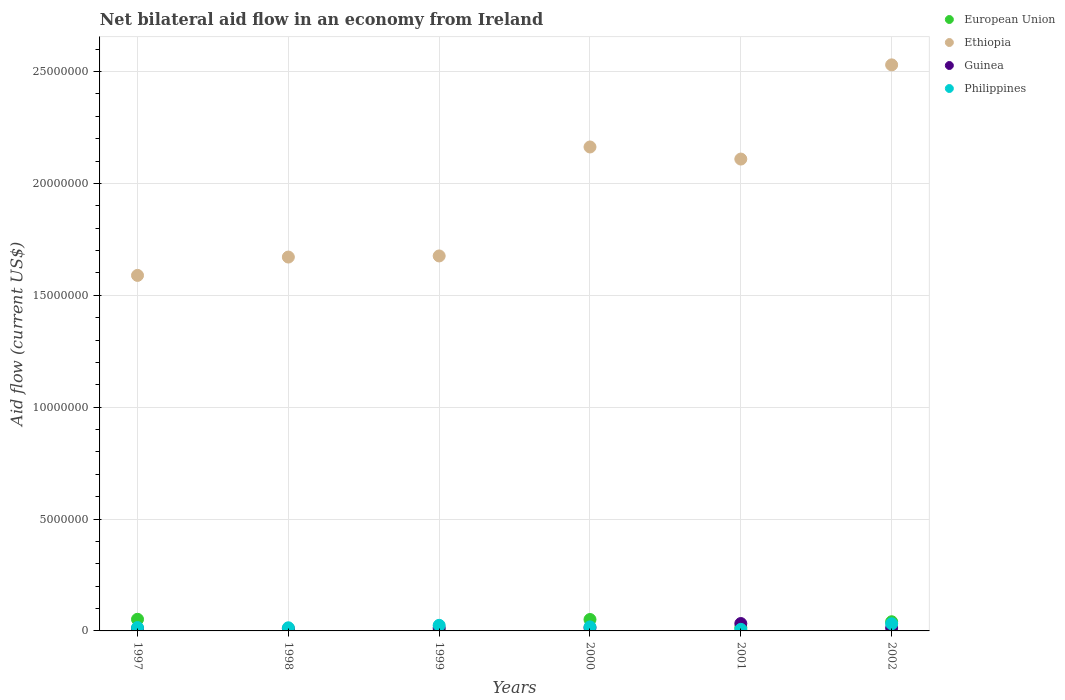Is the number of dotlines equal to the number of legend labels?
Offer a very short reply. Yes. Across all years, what is the maximum net bilateral aid flow in European Union?
Your answer should be compact. 5.20e+05. Across all years, what is the minimum net bilateral aid flow in Guinea?
Your answer should be compact. 1.00e+05. In which year was the net bilateral aid flow in Guinea minimum?
Your answer should be compact. 1998. What is the total net bilateral aid flow in Ethiopia in the graph?
Provide a succinct answer. 1.17e+08. What is the difference between the net bilateral aid flow in Ethiopia in 1997 and that in 2000?
Provide a succinct answer. -5.74e+06. What is the difference between the net bilateral aid flow in Philippines in 2001 and the net bilateral aid flow in Ethiopia in 2000?
Your answer should be compact. -2.16e+07. What is the average net bilateral aid flow in Guinea per year?
Your answer should be compact. 1.57e+05. In the year 2001, what is the difference between the net bilateral aid flow in Guinea and net bilateral aid flow in Ethiopia?
Provide a short and direct response. -2.08e+07. In how many years, is the net bilateral aid flow in Guinea greater than 13000000 US$?
Your answer should be very brief. 0. What is the ratio of the net bilateral aid flow in Philippines in 1997 to that in 2001?
Your answer should be very brief. 2.14. What is the difference between the highest and the lowest net bilateral aid flow in European Union?
Provide a succinct answer. 5.10e+05. In how many years, is the net bilateral aid flow in European Union greater than the average net bilateral aid flow in European Union taken over all years?
Give a very brief answer. 3. Is it the case that in every year, the sum of the net bilateral aid flow in European Union and net bilateral aid flow in Ethiopia  is greater than the sum of net bilateral aid flow in Guinea and net bilateral aid flow in Philippines?
Your answer should be very brief. No. Does the net bilateral aid flow in Guinea monotonically increase over the years?
Make the answer very short. No. Is the net bilateral aid flow in Ethiopia strictly greater than the net bilateral aid flow in European Union over the years?
Keep it short and to the point. Yes. How many years are there in the graph?
Your answer should be very brief. 6. What is the difference between two consecutive major ticks on the Y-axis?
Make the answer very short. 5.00e+06. Does the graph contain any zero values?
Provide a short and direct response. No. How many legend labels are there?
Your response must be concise. 4. What is the title of the graph?
Your answer should be very brief. Net bilateral aid flow in an economy from Ireland. Does "Maldives" appear as one of the legend labels in the graph?
Provide a short and direct response. No. What is the label or title of the X-axis?
Your answer should be very brief. Years. What is the Aid flow (current US$) in European Union in 1997?
Provide a short and direct response. 5.20e+05. What is the Aid flow (current US$) in Ethiopia in 1997?
Keep it short and to the point. 1.59e+07. What is the Aid flow (current US$) of Guinea in 1997?
Your answer should be very brief. 1.10e+05. What is the Aid flow (current US$) of Philippines in 1997?
Give a very brief answer. 1.50e+05. What is the Aid flow (current US$) in European Union in 1998?
Your answer should be very brief. 10000. What is the Aid flow (current US$) in Ethiopia in 1998?
Provide a succinct answer. 1.67e+07. What is the Aid flow (current US$) in Ethiopia in 1999?
Keep it short and to the point. 1.68e+07. What is the Aid flow (current US$) in European Union in 2000?
Offer a very short reply. 5.10e+05. What is the Aid flow (current US$) of Ethiopia in 2000?
Ensure brevity in your answer.  2.16e+07. What is the Aid flow (current US$) in European Union in 2001?
Keep it short and to the point. 1.50e+05. What is the Aid flow (current US$) of Ethiopia in 2001?
Your answer should be very brief. 2.11e+07. What is the Aid flow (current US$) of Guinea in 2001?
Offer a terse response. 3.30e+05. What is the Aid flow (current US$) in Ethiopia in 2002?
Your answer should be very brief. 2.53e+07. Across all years, what is the maximum Aid flow (current US$) of European Union?
Offer a terse response. 5.20e+05. Across all years, what is the maximum Aid flow (current US$) of Ethiopia?
Make the answer very short. 2.53e+07. Across all years, what is the maximum Aid flow (current US$) in Guinea?
Give a very brief answer. 3.30e+05. Across all years, what is the minimum Aid flow (current US$) in Ethiopia?
Provide a short and direct response. 1.59e+07. What is the total Aid flow (current US$) in European Union in the graph?
Offer a very short reply. 1.63e+06. What is the total Aid flow (current US$) of Ethiopia in the graph?
Your answer should be compact. 1.17e+08. What is the total Aid flow (current US$) of Guinea in the graph?
Your answer should be compact. 9.40e+05. What is the total Aid flow (current US$) of Philippines in the graph?
Your answer should be compact. 1.11e+06. What is the difference between the Aid flow (current US$) in European Union in 1997 and that in 1998?
Provide a succinct answer. 5.10e+05. What is the difference between the Aid flow (current US$) of Ethiopia in 1997 and that in 1998?
Make the answer very short. -8.20e+05. What is the difference between the Aid flow (current US$) of Guinea in 1997 and that in 1998?
Provide a short and direct response. 10000. What is the difference between the Aid flow (current US$) of Philippines in 1997 and that in 1998?
Offer a very short reply. 10000. What is the difference between the Aid flow (current US$) of European Union in 1997 and that in 1999?
Make the answer very short. 4.90e+05. What is the difference between the Aid flow (current US$) in Ethiopia in 1997 and that in 1999?
Your answer should be very brief. -8.70e+05. What is the difference between the Aid flow (current US$) of Guinea in 1997 and that in 1999?
Give a very brief answer. -2.00e+04. What is the difference between the Aid flow (current US$) in Philippines in 1997 and that in 1999?
Keep it short and to the point. -1.00e+05. What is the difference between the Aid flow (current US$) in European Union in 1997 and that in 2000?
Offer a very short reply. 10000. What is the difference between the Aid flow (current US$) in Ethiopia in 1997 and that in 2000?
Provide a short and direct response. -5.74e+06. What is the difference between the Aid flow (current US$) of Guinea in 1997 and that in 2000?
Your answer should be compact. -3.00e+04. What is the difference between the Aid flow (current US$) of European Union in 1997 and that in 2001?
Your answer should be very brief. 3.70e+05. What is the difference between the Aid flow (current US$) of Ethiopia in 1997 and that in 2001?
Keep it short and to the point. -5.20e+06. What is the difference between the Aid flow (current US$) of Guinea in 1997 and that in 2001?
Offer a terse response. -2.20e+05. What is the difference between the Aid flow (current US$) in Philippines in 1997 and that in 2001?
Give a very brief answer. 8.00e+04. What is the difference between the Aid flow (current US$) of European Union in 1997 and that in 2002?
Your answer should be compact. 1.10e+05. What is the difference between the Aid flow (current US$) in Ethiopia in 1997 and that in 2002?
Provide a short and direct response. -9.41e+06. What is the difference between the Aid flow (current US$) in Guinea in 1997 and that in 2002?
Provide a short and direct response. -2.00e+04. What is the difference between the Aid flow (current US$) of Philippines in 1997 and that in 2002?
Your response must be concise. -1.70e+05. What is the difference between the Aid flow (current US$) in European Union in 1998 and that in 1999?
Give a very brief answer. -2.00e+04. What is the difference between the Aid flow (current US$) of Ethiopia in 1998 and that in 1999?
Ensure brevity in your answer.  -5.00e+04. What is the difference between the Aid flow (current US$) in Guinea in 1998 and that in 1999?
Ensure brevity in your answer.  -3.00e+04. What is the difference between the Aid flow (current US$) of Philippines in 1998 and that in 1999?
Your answer should be compact. -1.10e+05. What is the difference between the Aid flow (current US$) of European Union in 1998 and that in 2000?
Your response must be concise. -5.00e+05. What is the difference between the Aid flow (current US$) of Ethiopia in 1998 and that in 2000?
Provide a short and direct response. -4.92e+06. What is the difference between the Aid flow (current US$) in Philippines in 1998 and that in 2000?
Give a very brief answer. -4.00e+04. What is the difference between the Aid flow (current US$) of European Union in 1998 and that in 2001?
Provide a short and direct response. -1.40e+05. What is the difference between the Aid flow (current US$) of Ethiopia in 1998 and that in 2001?
Your answer should be very brief. -4.38e+06. What is the difference between the Aid flow (current US$) of Philippines in 1998 and that in 2001?
Ensure brevity in your answer.  7.00e+04. What is the difference between the Aid flow (current US$) in European Union in 1998 and that in 2002?
Keep it short and to the point. -4.00e+05. What is the difference between the Aid flow (current US$) of Ethiopia in 1998 and that in 2002?
Make the answer very short. -8.59e+06. What is the difference between the Aid flow (current US$) of Guinea in 1998 and that in 2002?
Provide a short and direct response. -3.00e+04. What is the difference between the Aid flow (current US$) in European Union in 1999 and that in 2000?
Provide a short and direct response. -4.80e+05. What is the difference between the Aid flow (current US$) of Ethiopia in 1999 and that in 2000?
Offer a very short reply. -4.87e+06. What is the difference between the Aid flow (current US$) of Guinea in 1999 and that in 2000?
Keep it short and to the point. -10000. What is the difference between the Aid flow (current US$) in Ethiopia in 1999 and that in 2001?
Your response must be concise. -4.33e+06. What is the difference between the Aid flow (current US$) in Philippines in 1999 and that in 2001?
Ensure brevity in your answer.  1.80e+05. What is the difference between the Aid flow (current US$) of European Union in 1999 and that in 2002?
Your answer should be compact. -3.80e+05. What is the difference between the Aid flow (current US$) of Ethiopia in 1999 and that in 2002?
Your answer should be compact. -8.54e+06. What is the difference between the Aid flow (current US$) of Ethiopia in 2000 and that in 2001?
Provide a short and direct response. 5.40e+05. What is the difference between the Aid flow (current US$) in Guinea in 2000 and that in 2001?
Offer a terse response. -1.90e+05. What is the difference between the Aid flow (current US$) in Ethiopia in 2000 and that in 2002?
Offer a terse response. -3.67e+06. What is the difference between the Aid flow (current US$) in Guinea in 2000 and that in 2002?
Give a very brief answer. 10000. What is the difference between the Aid flow (current US$) of Philippines in 2000 and that in 2002?
Your answer should be compact. -1.40e+05. What is the difference between the Aid flow (current US$) in European Union in 2001 and that in 2002?
Your answer should be compact. -2.60e+05. What is the difference between the Aid flow (current US$) in Ethiopia in 2001 and that in 2002?
Offer a terse response. -4.21e+06. What is the difference between the Aid flow (current US$) in Philippines in 2001 and that in 2002?
Your response must be concise. -2.50e+05. What is the difference between the Aid flow (current US$) in European Union in 1997 and the Aid flow (current US$) in Ethiopia in 1998?
Provide a short and direct response. -1.62e+07. What is the difference between the Aid flow (current US$) in European Union in 1997 and the Aid flow (current US$) in Guinea in 1998?
Your response must be concise. 4.20e+05. What is the difference between the Aid flow (current US$) of European Union in 1997 and the Aid flow (current US$) of Philippines in 1998?
Keep it short and to the point. 3.80e+05. What is the difference between the Aid flow (current US$) in Ethiopia in 1997 and the Aid flow (current US$) in Guinea in 1998?
Offer a terse response. 1.58e+07. What is the difference between the Aid flow (current US$) of Ethiopia in 1997 and the Aid flow (current US$) of Philippines in 1998?
Make the answer very short. 1.58e+07. What is the difference between the Aid flow (current US$) of European Union in 1997 and the Aid flow (current US$) of Ethiopia in 1999?
Provide a succinct answer. -1.62e+07. What is the difference between the Aid flow (current US$) of European Union in 1997 and the Aid flow (current US$) of Guinea in 1999?
Give a very brief answer. 3.90e+05. What is the difference between the Aid flow (current US$) in Ethiopia in 1997 and the Aid flow (current US$) in Guinea in 1999?
Your response must be concise. 1.58e+07. What is the difference between the Aid flow (current US$) of Ethiopia in 1997 and the Aid flow (current US$) of Philippines in 1999?
Give a very brief answer. 1.56e+07. What is the difference between the Aid flow (current US$) of European Union in 1997 and the Aid flow (current US$) of Ethiopia in 2000?
Keep it short and to the point. -2.11e+07. What is the difference between the Aid flow (current US$) in Ethiopia in 1997 and the Aid flow (current US$) in Guinea in 2000?
Your answer should be very brief. 1.58e+07. What is the difference between the Aid flow (current US$) of Ethiopia in 1997 and the Aid flow (current US$) of Philippines in 2000?
Offer a terse response. 1.57e+07. What is the difference between the Aid flow (current US$) in European Union in 1997 and the Aid flow (current US$) in Ethiopia in 2001?
Your response must be concise. -2.06e+07. What is the difference between the Aid flow (current US$) in European Union in 1997 and the Aid flow (current US$) in Guinea in 2001?
Ensure brevity in your answer.  1.90e+05. What is the difference between the Aid flow (current US$) of European Union in 1997 and the Aid flow (current US$) of Philippines in 2001?
Your answer should be very brief. 4.50e+05. What is the difference between the Aid flow (current US$) in Ethiopia in 1997 and the Aid flow (current US$) in Guinea in 2001?
Your response must be concise. 1.56e+07. What is the difference between the Aid flow (current US$) in Ethiopia in 1997 and the Aid flow (current US$) in Philippines in 2001?
Offer a very short reply. 1.58e+07. What is the difference between the Aid flow (current US$) of Guinea in 1997 and the Aid flow (current US$) of Philippines in 2001?
Offer a terse response. 4.00e+04. What is the difference between the Aid flow (current US$) of European Union in 1997 and the Aid flow (current US$) of Ethiopia in 2002?
Ensure brevity in your answer.  -2.48e+07. What is the difference between the Aid flow (current US$) of European Union in 1997 and the Aid flow (current US$) of Guinea in 2002?
Your response must be concise. 3.90e+05. What is the difference between the Aid flow (current US$) in Ethiopia in 1997 and the Aid flow (current US$) in Guinea in 2002?
Offer a terse response. 1.58e+07. What is the difference between the Aid flow (current US$) in Ethiopia in 1997 and the Aid flow (current US$) in Philippines in 2002?
Provide a short and direct response. 1.56e+07. What is the difference between the Aid flow (current US$) of European Union in 1998 and the Aid flow (current US$) of Ethiopia in 1999?
Provide a short and direct response. -1.68e+07. What is the difference between the Aid flow (current US$) in Ethiopia in 1998 and the Aid flow (current US$) in Guinea in 1999?
Your answer should be compact. 1.66e+07. What is the difference between the Aid flow (current US$) of Ethiopia in 1998 and the Aid flow (current US$) of Philippines in 1999?
Your response must be concise. 1.65e+07. What is the difference between the Aid flow (current US$) in Guinea in 1998 and the Aid flow (current US$) in Philippines in 1999?
Ensure brevity in your answer.  -1.50e+05. What is the difference between the Aid flow (current US$) of European Union in 1998 and the Aid flow (current US$) of Ethiopia in 2000?
Provide a short and direct response. -2.16e+07. What is the difference between the Aid flow (current US$) of European Union in 1998 and the Aid flow (current US$) of Guinea in 2000?
Ensure brevity in your answer.  -1.30e+05. What is the difference between the Aid flow (current US$) of European Union in 1998 and the Aid flow (current US$) of Philippines in 2000?
Offer a very short reply. -1.70e+05. What is the difference between the Aid flow (current US$) of Ethiopia in 1998 and the Aid flow (current US$) of Guinea in 2000?
Provide a succinct answer. 1.66e+07. What is the difference between the Aid flow (current US$) in Ethiopia in 1998 and the Aid flow (current US$) in Philippines in 2000?
Your response must be concise. 1.65e+07. What is the difference between the Aid flow (current US$) of Guinea in 1998 and the Aid flow (current US$) of Philippines in 2000?
Provide a succinct answer. -8.00e+04. What is the difference between the Aid flow (current US$) of European Union in 1998 and the Aid flow (current US$) of Ethiopia in 2001?
Keep it short and to the point. -2.11e+07. What is the difference between the Aid flow (current US$) of European Union in 1998 and the Aid flow (current US$) of Guinea in 2001?
Your answer should be very brief. -3.20e+05. What is the difference between the Aid flow (current US$) of European Union in 1998 and the Aid flow (current US$) of Philippines in 2001?
Give a very brief answer. -6.00e+04. What is the difference between the Aid flow (current US$) in Ethiopia in 1998 and the Aid flow (current US$) in Guinea in 2001?
Offer a terse response. 1.64e+07. What is the difference between the Aid flow (current US$) of Ethiopia in 1998 and the Aid flow (current US$) of Philippines in 2001?
Provide a short and direct response. 1.66e+07. What is the difference between the Aid flow (current US$) of European Union in 1998 and the Aid flow (current US$) of Ethiopia in 2002?
Give a very brief answer. -2.53e+07. What is the difference between the Aid flow (current US$) of European Union in 1998 and the Aid flow (current US$) of Guinea in 2002?
Make the answer very short. -1.20e+05. What is the difference between the Aid flow (current US$) of European Union in 1998 and the Aid flow (current US$) of Philippines in 2002?
Keep it short and to the point. -3.10e+05. What is the difference between the Aid flow (current US$) in Ethiopia in 1998 and the Aid flow (current US$) in Guinea in 2002?
Ensure brevity in your answer.  1.66e+07. What is the difference between the Aid flow (current US$) in Ethiopia in 1998 and the Aid flow (current US$) in Philippines in 2002?
Give a very brief answer. 1.64e+07. What is the difference between the Aid flow (current US$) in European Union in 1999 and the Aid flow (current US$) in Ethiopia in 2000?
Give a very brief answer. -2.16e+07. What is the difference between the Aid flow (current US$) in European Union in 1999 and the Aid flow (current US$) in Philippines in 2000?
Your answer should be very brief. -1.50e+05. What is the difference between the Aid flow (current US$) of Ethiopia in 1999 and the Aid flow (current US$) of Guinea in 2000?
Give a very brief answer. 1.66e+07. What is the difference between the Aid flow (current US$) of Ethiopia in 1999 and the Aid flow (current US$) of Philippines in 2000?
Give a very brief answer. 1.66e+07. What is the difference between the Aid flow (current US$) of Guinea in 1999 and the Aid flow (current US$) of Philippines in 2000?
Keep it short and to the point. -5.00e+04. What is the difference between the Aid flow (current US$) in European Union in 1999 and the Aid flow (current US$) in Ethiopia in 2001?
Provide a succinct answer. -2.11e+07. What is the difference between the Aid flow (current US$) in Ethiopia in 1999 and the Aid flow (current US$) in Guinea in 2001?
Provide a succinct answer. 1.64e+07. What is the difference between the Aid flow (current US$) in Ethiopia in 1999 and the Aid flow (current US$) in Philippines in 2001?
Keep it short and to the point. 1.67e+07. What is the difference between the Aid flow (current US$) of Guinea in 1999 and the Aid flow (current US$) of Philippines in 2001?
Your answer should be compact. 6.00e+04. What is the difference between the Aid flow (current US$) of European Union in 1999 and the Aid flow (current US$) of Ethiopia in 2002?
Provide a short and direct response. -2.53e+07. What is the difference between the Aid flow (current US$) of European Union in 1999 and the Aid flow (current US$) of Guinea in 2002?
Keep it short and to the point. -1.00e+05. What is the difference between the Aid flow (current US$) in European Union in 1999 and the Aid flow (current US$) in Philippines in 2002?
Ensure brevity in your answer.  -2.90e+05. What is the difference between the Aid flow (current US$) in Ethiopia in 1999 and the Aid flow (current US$) in Guinea in 2002?
Offer a terse response. 1.66e+07. What is the difference between the Aid flow (current US$) of Ethiopia in 1999 and the Aid flow (current US$) of Philippines in 2002?
Provide a short and direct response. 1.64e+07. What is the difference between the Aid flow (current US$) in Guinea in 1999 and the Aid flow (current US$) in Philippines in 2002?
Your response must be concise. -1.90e+05. What is the difference between the Aid flow (current US$) of European Union in 2000 and the Aid flow (current US$) of Ethiopia in 2001?
Provide a succinct answer. -2.06e+07. What is the difference between the Aid flow (current US$) in European Union in 2000 and the Aid flow (current US$) in Philippines in 2001?
Give a very brief answer. 4.40e+05. What is the difference between the Aid flow (current US$) in Ethiopia in 2000 and the Aid flow (current US$) in Guinea in 2001?
Provide a short and direct response. 2.13e+07. What is the difference between the Aid flow (current US$) of Ethiopia in 2000 and the Aid flow (current US$) of Philippines in 2001?
Offer a very short reply. 2.16e+07. What is the difference between the Aid flow (current US$) in Guinea in 2000 and the Aid flow (current US$) in Philippines in 2001?
Provide a succinct answer. 7.00e+04. What is the difference between the Aid flow (current US$) in European Union in 2000 and the Aid flow (current US$) in Ethiopia in 2002?
Offer a terse response. -2.48e+07. What is the difference between the Aid flow (current US$) of European Union in 2000 and the Aid flow (current US$) of Guinea in 2002?
Keep it short and to the point. 3.80e+05. What is the difference between the Aid flow (current US$) in Ethiopia in 2000 and the Aid flow (current US$) in Guinea in 2002?
Keep it short and to the point. 2.15e+07. What is the difference between the Aid flow (current US$) of Ethiopia in 2000 and the Aid flow (current US$) of Philippines in 2002?
Provide a succinct answer. 2.13e+07. What is the difference between the Aid flow (current US$) of Guinea in 2000 and the Aid flow (current US$) of Philippines in 2002?
Provide a short and direct response. -1.80e+05. What is the difference between the Aid flow (current US$) in European Union in 2001 and the Aid flow (current US$) in Ethiopia in 2002?
Ensure brevity in your answer.  -2.52e+07. What is the difference between the Aid flow (current US$) in Ethiopia in 2001 and the Aid flow (current US$) in Guinea in 2002?
Offer a terse response. 2.10e+07. What is the difference between the Aid flow (current US$) in Ethiopia in 2001 and the Aid flow (current US$) in Philippines in 2002?
Provide a short and direct response. 2.08e+07. What is the difference between the Aid flow (current US$) of Guinea in 2001 and the Aid flow (current US$) of Philippines in 2002?
Your answer should be very brief. 10000. What is the average Aid flow (current US$) in European Union per year?
Offer a very short reply. 2.72e+05. What is the average Aid flow (current US$) of Ethiopia per year?
Provide a succinct answer. 1.96e+07. What is the average Aid flow (current US$) of Guinea per year?
Offer a terse response. 1.57e+05. What is the average Aid flow (current US$) of Philippines per year?
Offer a terse response. 1.85e+05. In the year 1997, what is the difference between the Aid flow (current US$) in European Union and Aid flow (current US$) in Ethiopia?
Your response must be concise. -1.54e+07. In the year 1997, what is the difference between the Aid flow (current US$) of European Union and Aid flow (current US$) of Guinea?
Keep it short and to the point. 4.10e+05. In the year 1997, what is the difference between the Aid flow (current US$) in Ethiopia and Aid flow (current US$) in Guinea?
Your answer should be compact. 1.58e+07. In the year 1997, what is the difference between the Aid flow (current US$) of Ethiopia and Aid flow (current US$) of Philippines?
Offer a very short reply. 1.57e+07. In the year 1998, what is the difference between the Aid flow (current US$) of European Union and Aid flow (current US$) of Ethiopia?
Give a very brief answer. -1.67e+07. In the year 1998, what is the difference between the Aid flow (current US$) in European Union and Aid flow (current US$) in Guinea?
Give a very brief answer. -9.00e+04. In the year 1998, what is the difference between the Aid flow (current US$) of European Union and Aid flow (current US$) of Philippines?
Your answer should be very brief. -1.30e+05. In the year 1998, what is the difference between the Aid flow (current US$) of Ethiopia and Aid flow (current US$) of Guinea?
Provide a succinct answer. 1.66e+07. In the year 1998, what is the difference between the Aid flow (current US$) of Ethiopia and Aid flow (current US$) of Philippines?
Make the answer very short. 1.66e+07. In the year 1999, what is the difference between the Aid flow (current US$) of European Union and Aid flow (current US$) of Ethiopia?
Your response must be concise. -1.67e+07. In the year 1999, what is the difference between the Aid flow (current US$) of Ethiopia and Aid flow (current US$) of Guinea?
Your response must be concise. 1.66e+07. In the year 1999, what is the difference between the Aid flow (current US$) of Ethiopia and Aid flow (current US$) of Philippines?
Offer a very short reply. 1.65e+07. In the year 1999, what is the difference between the Aid flow (current US$) of Guinea and Aid flow (current US$) of Philippines?
Give a very brief answer. -1.20e+05. In the year 2000, what is the difference between the Aid flow (current US$) of European Union and Aid flow (current US$) of Ethiopia?
Ensure brevity in your answer.  -2.11e+07. In the year 2000, what is the difference between the Aid flow (current US$) of Ethiopia and Aid flow (current US$) of Guinea?
Give a very brief answer. 2.15e+07. In the year 2000, what is the difference between the Aid flow (current US$) in Ethiopia and Aid flow (current US$) in Philippines?
Ensure brevity in your answer.  2.14e+07. In the year 2000, what is the difference between the Aid flow (current US$) of Guinea and Aid flow (current US$) of Philippines?
Make the answer very short. -4.00e+04. In the year 2001, what is the difference between the Aid flow (current US$) of European Union and Aid flow (current US$) of Ethiopia?
Offer a very short reply. -2.09e+07. In the year 2001, what is the difference between the Aid flow (current US$) in Ethiopia and Aid flow (current US$) in Guinea?
Make the answer very short. 2.08e+07. In the year 2001, what is the difference between the Aid flow (current US$) in Ethiopia and Aid flow (current US$) in Philippines?
Provide a short and direct response. 2.10e+07. In the year 2001, what is the difference between the Aid flow (current US$) of Guinea and Aid flow (current US$) of Philippines?
Provide a short and direct response. 2.60e+05. In the year 2002, what is the difference between the Aid flow (current US$) of European Union and Aid flow (current US$) of Ethiopia?
Provide a succinct answer. -2.49e+07. In the year 2002, what is the difference between the Aid flow (current US$) in European Union and Aid flow (current US$) in Philippines?
Give a very brief answer. 9.00e+04. In the year 2002, what is the difference between the Aid flow (current US$) of Ethiopia and Aid flow (current US$) of Guinea?
Your answer should be very brief. 2.52e+07. In the year 2002, what is the difference between the Aid flow (current US$) of Ethiopia and Aid flow (current US$) of Philippines?
Provide a succinct answer. 2.50e+07. What is the ratio of the Aid flow (current US$) of European Union in 1997 to that in 1998?
Offer a very short reply. 52. What is the ratio of the Aid flow (current US$) in Ethiopia in 1997 to that in 1998?
Provide a succinct answer. 0.95. What is the ratio of the Aid flow (current US$) of Philippines in 1997 to that in 1998?
Your answer should be very brief. 1.07. What is the ratio of the Aid flow (current US$) in European Union in 1997 to that in 1999?
Keep it short and to the point. 17.33. What is the ratio of the Aid flow (current US$) in Ethiopia in 1997 to that in 1999?
Your response must be concise. 0.95. What is the ratio of the Aid flow (current US$) in Guinea in 1997 to that in 1999?
Keep it short and to the point. 0.85. What is the ratio of the Aid flow (current US$) of European Union in 1997 to that in 2000?
Keep it short and to the point. 1.02. What is the ratio of the Aid flow (current US$) in Ethiopia in 1997 to that in 2000?
Provide a short and direct response. 0.73. What is the ratio of the Aid flow (current US$) in Guinea in 1997 to that in 2000?
Your response must be concise. 0.79. What is the ratio of the Aid flow (current US$) of European Union in 1997 to that in 2001?
Provide a succinct answer. 3.47. What is the ratio of the Aid flow (current US$) in Ethiopia in 1997 to that in 2001?
Provide a short and direct response. 0.75. What is the ratio of the Aid flow (current US$) of Guinea in 1997 to that in 2001?
Provide a succinct answer. 0.33. What is the ratio of the Aid flow (current US$) of Philippines in 1997 to that in 2001?
Keep it short and to the point. 2.14. What is the ratio of the Aid flow (current US$) in European Union in 1997 to that in 2002?
Ensure brevity in your answer.  1.27. What is the ratio of the Aid flow (current US$) in Ethiopia in 1997 to that in 2002?
Your answer should be compact. 0.63. What is the ratio of the Aid flow (current US$) in Guinea in 1997 to that in 2002?
Provide a succinct answer. 0.85. What is the ratio of the Aid flow (current US$) in Philippines in 1997 to that in 2002?
Keep it short and to the point. 0.47. What is the ratio of the Aid flow (current US$) of European Union in 1998 to that in 1999?
Make the answer very short. 0.33. What is the ratio of the Aid flow (current US$) of Ethiopia in 1998 to that in 1999?
Ensure brevity in your answer.  1. What is the ratio of the Aid flow (current US$) of Guinea in 1998 to that in 1999?
Provide a succinct answer. 0.77. What is the ratio of the Aid flow (current US$) in Philippines in 1998 to that in 1999?
Your answer should be compact. 0.56. What is the ratio of the Aid flow (current US$) of European Union in 1998 to that in 2000?
Your answer should be compact. 0.02. What is the ratio of the Aid flow (current US$) in Ethiopia in 1998 to that in 2000?
Your answer should be very brief. 0.77. What is the ratio of the Aid flow (current US$) of Guinea in 1998 to that in 2000?
Offer a very short reply. 0.71. What is the ratio of the Aid flow (current US$) in European Union in 1998 to that in 2001?
Offer a very short reply. 0.07. What is the ratio of the Aid flow (current US$) of Ethiopia in 1998 to that in 2001?
Your answer should be compact. 0.79. What is the ratio of the Aid flow (current US$) of Guinea in 1998 to that in 2001?
Offer a terse response. 0.3. What is the ratio of the Aid flow (current US$) of Philippines in 1998 to that in 2001?
Provide a succinct answer. 2. What is the ratio of the Aid flow (current US$) of European Union in 1998 to that in 2002?
Offer a very short reply. 0.02. What is the ratio of the Aid flow (current US$) in Ethiopia in 1998 to that in 2002?
Provide a short and direct response. 0.66. What is the ratio of the Aid flow (current US$) of Guinea in 1998 to that in 2002?
Ensure brevity in your answer.  0.77. What is the ratio of the Aid flow (current US$) in Philippines in 1998 to that in 2002?
Your answer should be very brief. 0.44. What is the ratio of the Aid flow (current US$) of European Union in 1999 to that in 2000?
Provide a short and direct response. 0.06. What is the ratio of the Aid flow (current US$) of Ethiopia in 1999 to that in 2000?
Offer a very short reply. 0.77. What is the ratio of the Aid flow (current US$) of Guinea in 1999 to that in 2000?
Offer a very short reply. 0.93. What is the ratio of the Aid flow (current US$) of Philippines in 1999 to that in 2000?
Give a very brief answer. 1.39. What is the ratio of the Aid flow (current US$) in European Union in 1999 to that in 2001?
Keep it short and to the point. 0.2. What is the ratio of the Aid flow (current US$) in Ethiopia in 1999 to that in 2001?
Offer a very short reply. 0.79. What is the ratio of the Aid flow (current US$) of Guinea in 1999 to that in 2001?
Offer a terse response. 0.39. What is the ratio of the Aid flow (current US$) in Philippines in 1999 to that in 2001?
Make the answer very short. 3.57. What is the ratio of the Aid flow (current US$) in European Union in 1999 to that in 2002?
Offer a terse response. 0.07. What is the ratio of the Aid flow (current US$) of Ethiopia in 1999 to that in 2002?
Provide a succinct answer. 0.66. What is the ratio of the Aid flow (current US$) in Guinea in 1999 to that in 2002?
Offer a very short reply. 1. What is the ratio of the Aid flow (current US$) in Philippines in 1999 to that in 2002?
Your response must be concise. 0.78. What is the ratio of the Aid flow (current US$) of European Union in 2000 to that in 2001?
Your response must be concise. 3.4. What is the ratio of the Aid flow (current US$) of Ethiopia in 2000 to that in 2001?
Your answer should be compact. 1.03. What is the ratio of the Aid flow (current US$) in Guinea in 2000 to that in 2001?
Provide a short and direct response. 0.42. What is the ratio of the Aid flow (current US$) of Philippines in 2000 to that in 2001?
Your answer should be very brief. 2.57. What is the ratio of the Aid flow (current US$) of European Union in 2000 to that in 2002?
Your response must be concise. 1.24. What is the ratio of the Aid flow (current US$) in Ethiopia in 2000 to that in 2002?
Your answer should be compact. 0.85. What is the ratio of the Aid flow (current US$) of Philippines in 2000 to that in 2002?
Your answer should be very brief. 0.56. What is the ratio of the Aid flow (current US$) of European Union in 2001 to that in 2002?
Provide a succinct answer. 0.37. What is the ratio of the Aid flow (current US$) in Ethiopia in 2001 to that in 2002?
Offer a very short reply. 0.83. What is the ratio of the Aid flow (current US$) in Guinea in 2001 to that in 2002?
Keep it short and to the point. 2.54. What is the ratio of the Aid flow (current US$) of Philippines in 2001 to that in 2002?
Offer a terse response. 0.22. What is the difference between the highest and the second highest Aid flow (current US$) of European Union?
Keep it short and to the point. 10000. What is the difference between the highest and the second highest Aid flow (current US$) of Ethiopia?
Provide a short and direct response. 3.67e+06. What is the difference between the highest and the second highest Aid flow (current US$) of Philippines?
Your answer should be very brief. 7.00e+04. What is the difference between the highest and the lowest Aid flow (current US$) in European Union?
Keep it short and to the point. 5.10e+05. What is the difference between the highest and the lowest Aid flow (current US$) in Ethiopia?
Ensure brevity in your answer.  9.41e+06. 